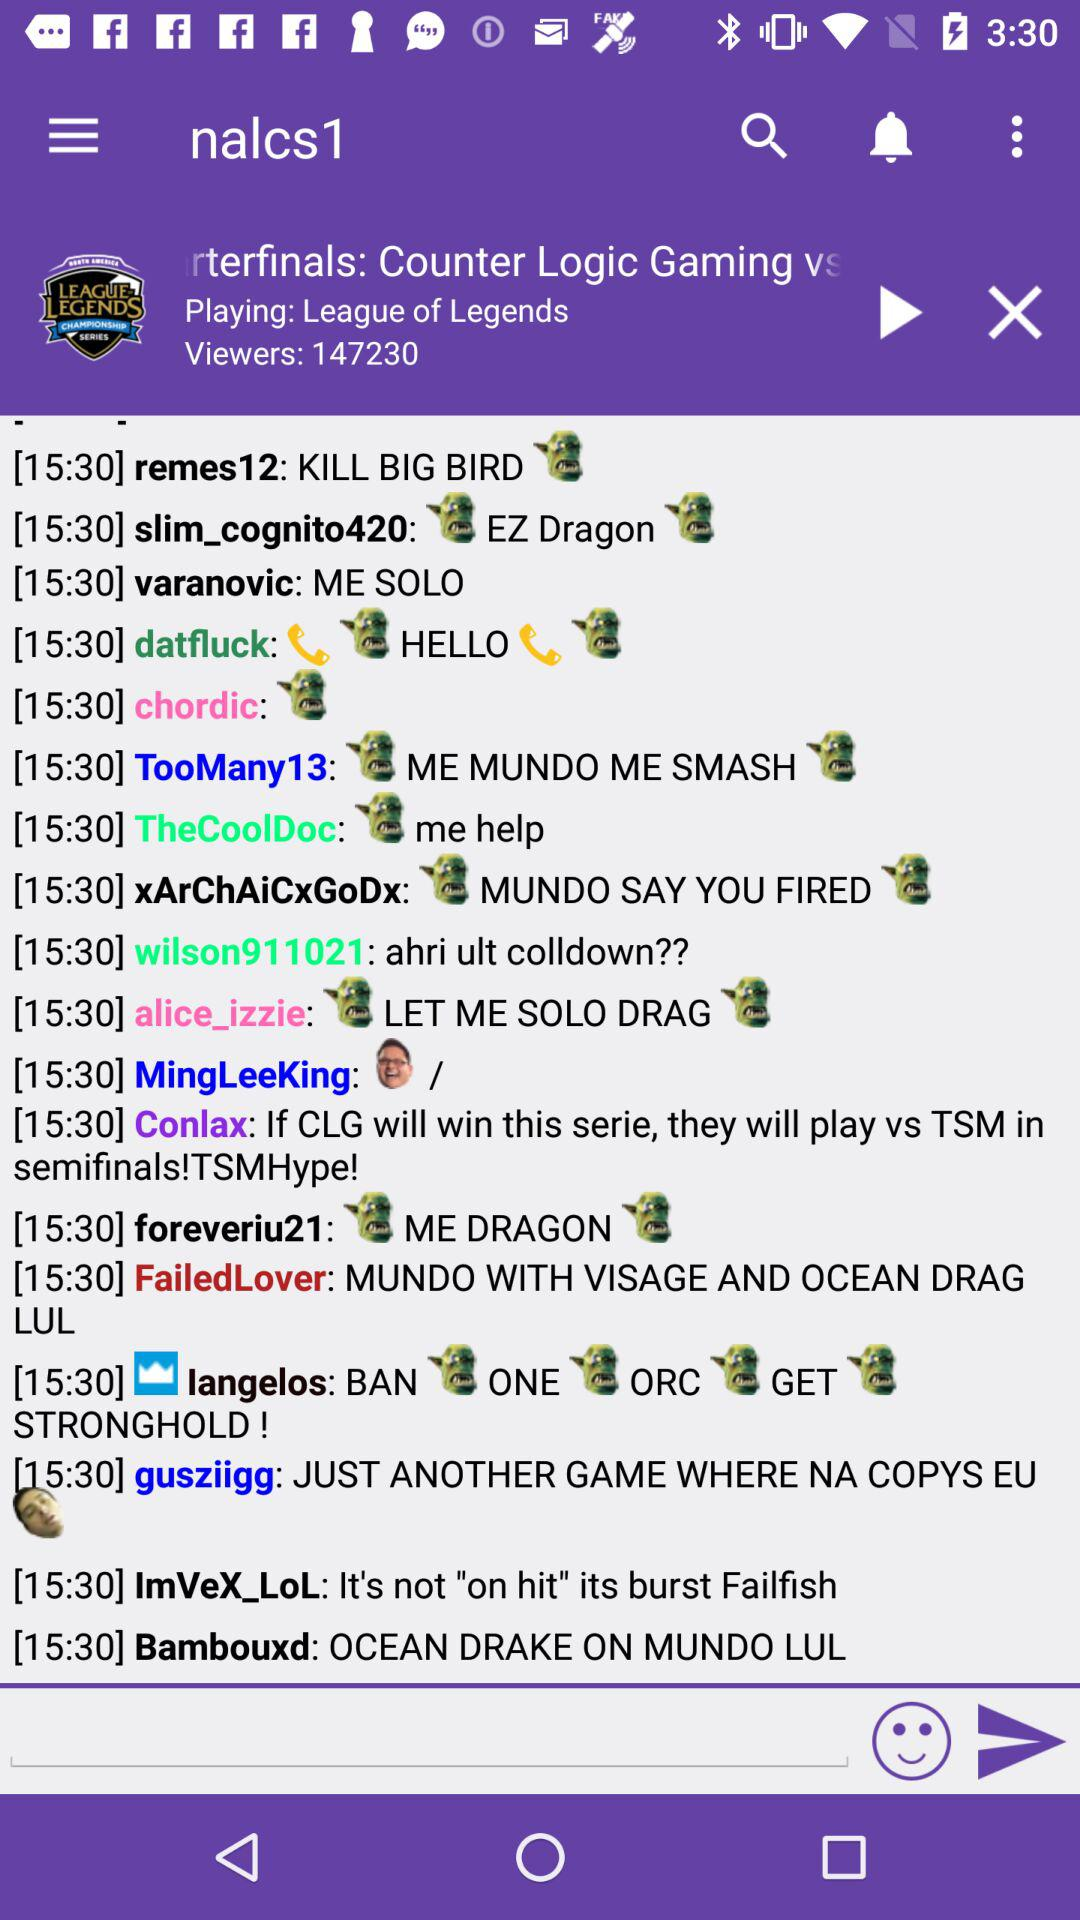How many player reviews are there?
When the provided information is insufficient, respond with <no answer>. <no answer> 